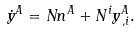Convert formula to latex. <formula><loc_0><loc_0><loc_500><loc_500>\dot { y } ^ { A } = N n ^ { A } + N ^ { i } y ^ { A } _ { \, , i } .</formula> 